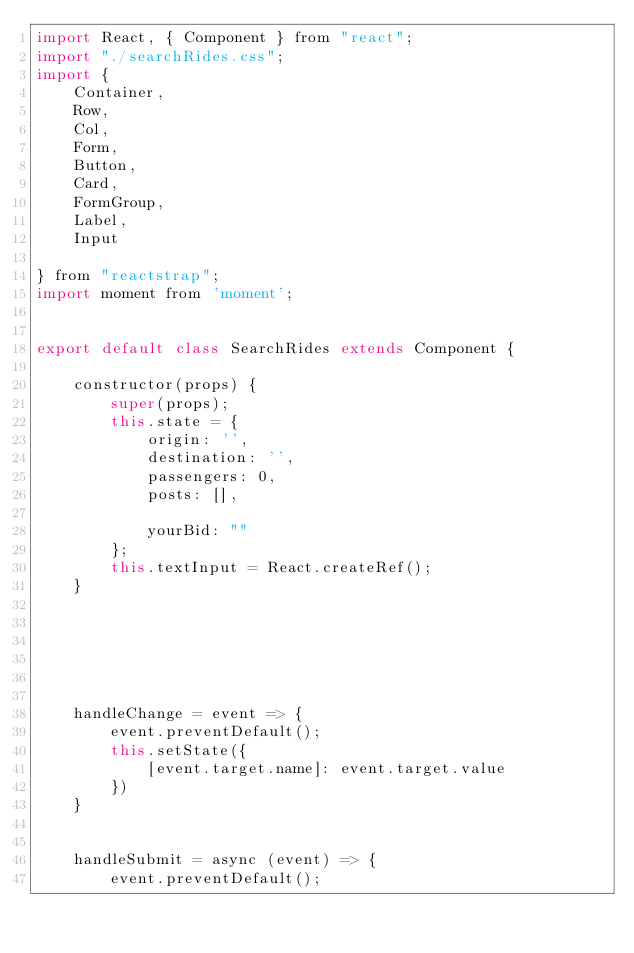<code> <loc_0><loc_0><loc_500><loc_500><_JavaScript_>import React, { Component } from "react";
import "./searchRides.css";
import {
    Container,
    Row,
    Col,
    Form,
    Button,
    Card,
    FormGroup,
    Label,
    Input

} from "reactstrap";
import moment from 'moment';


export default class SearchRides extends Component {

    constructor(props) {
        super(props);
        this.state = {
            origin: '',
            destination: '',
            passengers: 0,
            posts: [],

            yourBid: ""
        };
        this.textInput = React.createRef();
    }






    handleChange = event => {
        event.preventDefault();
        this.setState({
            [event.target.name]: event.target.value
        })
    }


    handleSubmit = async (event) => {
        event.preventDefault();</code> 